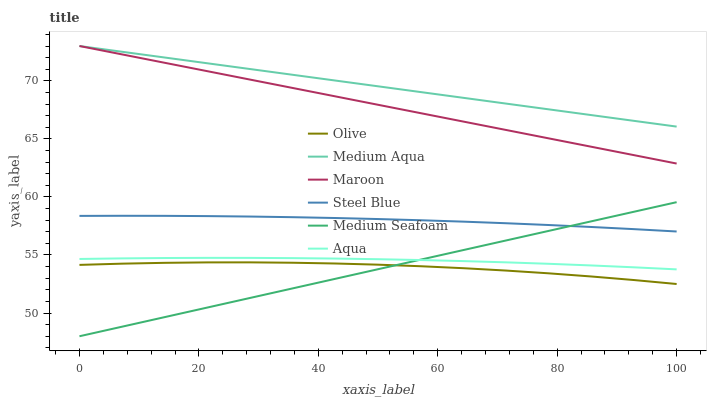Does Medium Seafoam have the minimum area under the curve?
Answer yes or no. Yes. Does Medium Aqua have the maximum area under the curve?
Answer yes or no. Yes. Does Steel Blue have the minimum area under the curve?
Answer yes or no. No. Does Steel Blue have the maximum area under the curve?
Answer yes or no. No. Is Medium Seafoam the smoothest?
Answer yes or no. Yes. Is Olive the roughest?
Answer yes or no. Yes. Is Steel Blue the smoothest?
Answer yes or no. No. Is Steel Blue the roughest?
Answer yes or no. No. Does Steel Blue have the lowest value?
Answer yes or no. No. Does Medium Aqua have the highest value?
Answer yes or no. Yes. Does Steel Blue have the highest value?
Answer yes or no. No. Is Steel Blue less than Maroon?
Answer yes or no. Yes. Is Medium Aqua greater than Medium Seafoam?
Answer yes or no. Yes. Does Aqua intersect Medium Seafoam?
Answer yes or no. Yes. Is Aqua less than Medium Seafoam?
Answer yes or no. No. Is Aqua greater than Medium Seafoam?
Answer yes or no. No. Does Steel Blue intersect Maroon?
Answer yes or no. No. 